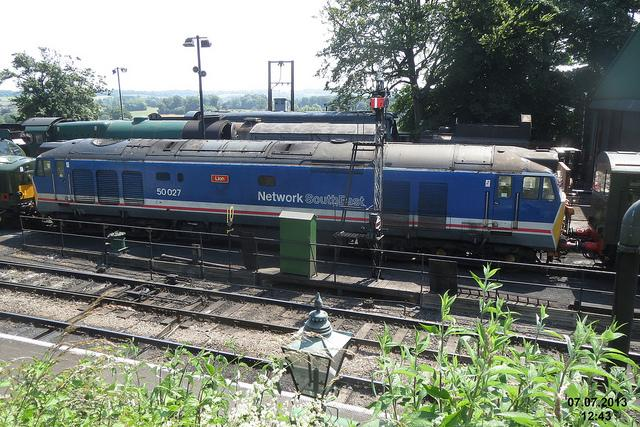What is the first number that appears on the train? five 